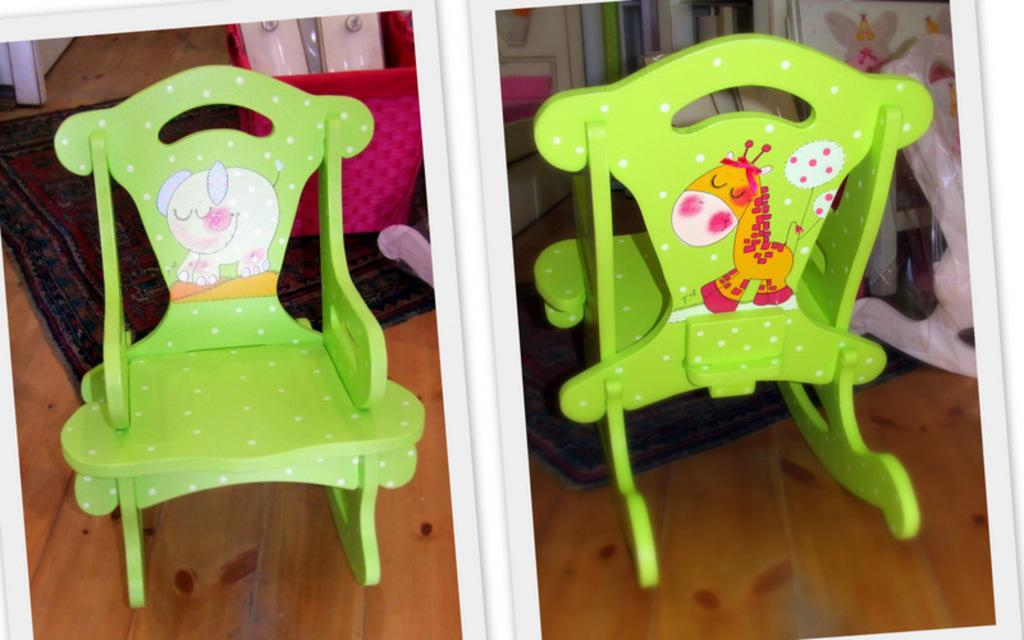What type of image is being described? The image is a collage of multiple pictures. Can you describe any specific objects or elements in the collage? Yes, there are green chairs on the floor and mats in one of the pictures. What color is the pink object in one of the pictures? The pink object in one of the pictures is pink. What type of alley can be seen in the background of one of the pictures? There is no alley present in the image; it is a collage of multiple pictures with green chairs, mats, and a pink object. 